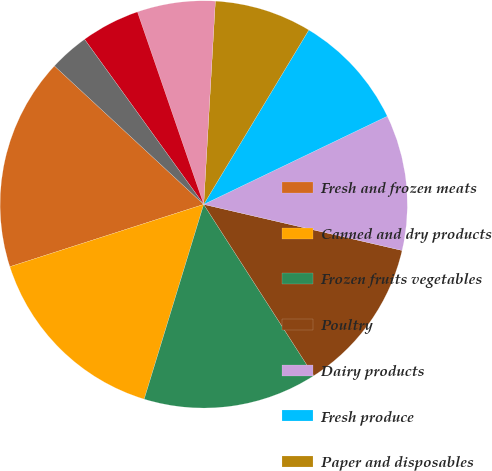<chart> <loc_0><loc_0><loc_500><loc_500><pie_chart><fcel>Fresh and frozen meats<fcel>Canned and dry products<fcel>Frozen fruits vegetables<fcel>Poultry<fcel>Dairy products<fcel>Fresh produce<fcel>Paper and disposables<fcel>Seafood<fcel>Beverage products<fcel>Equipment and smallwares<nl><fcel>16.85%<fcel>15.33%<fcel>13.81%<fcel>12.28%<fcel>10.76%<fcel>9.24%<fcel>7.72%<fcel>6.19%<fcel>4.67%<fcel>3.15%<nl></chart> 